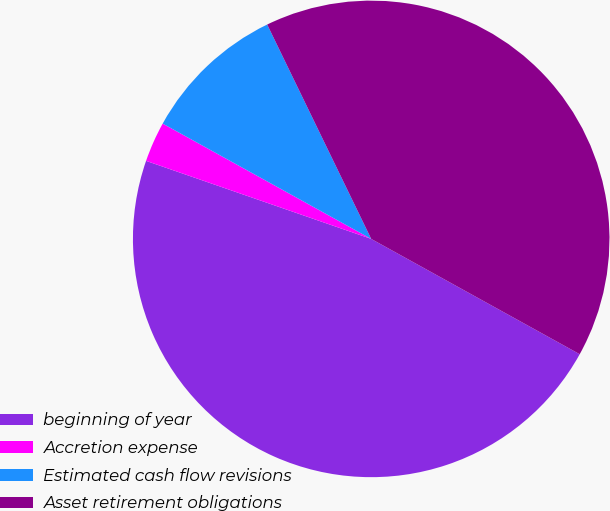Convert chart. <chart><loc_0><loc_0><loc_500><loc_500><pie_chart><fcel>beginning of year<fcel>Accretion expense<fcel>Estimated cash flow revisions<fcel>Asset retirement obligations<nl><fcel>47.27%<fcel>2.73%<fcel>9.77%<fcel>40.23%<nl></chart> 